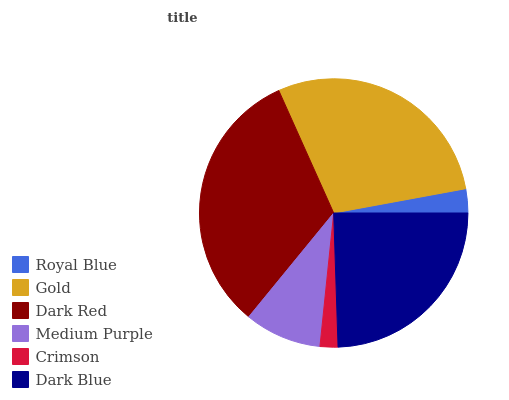Is Crimson the minimum?
Answer yes or no. Yes. Is Dark Red the maximum?
Answer yes or no. Yes. Is Gold the minimum?
Answer yes or no. No. Is Gold the maximum?
Answer yes or no. No. Is Gold greater than Royal Blue?
Answer yes or no. Yes. Is Royal Blue less than Gold?
Answer yes or no. Yes. Is Royal Blue greater than Gold?
Answer yes or no. No. Is Gold less than Royal Blue?
Answer yes or no. No. Is Dark Blue the high median?
Answer yes or no. Yes. Is Medium Purple the low median?
Answer yes or no. Yes. Is Gold the high median?
Answer yes or no. No. Is Dark Blue the low median?
Answer yes or no. No. 